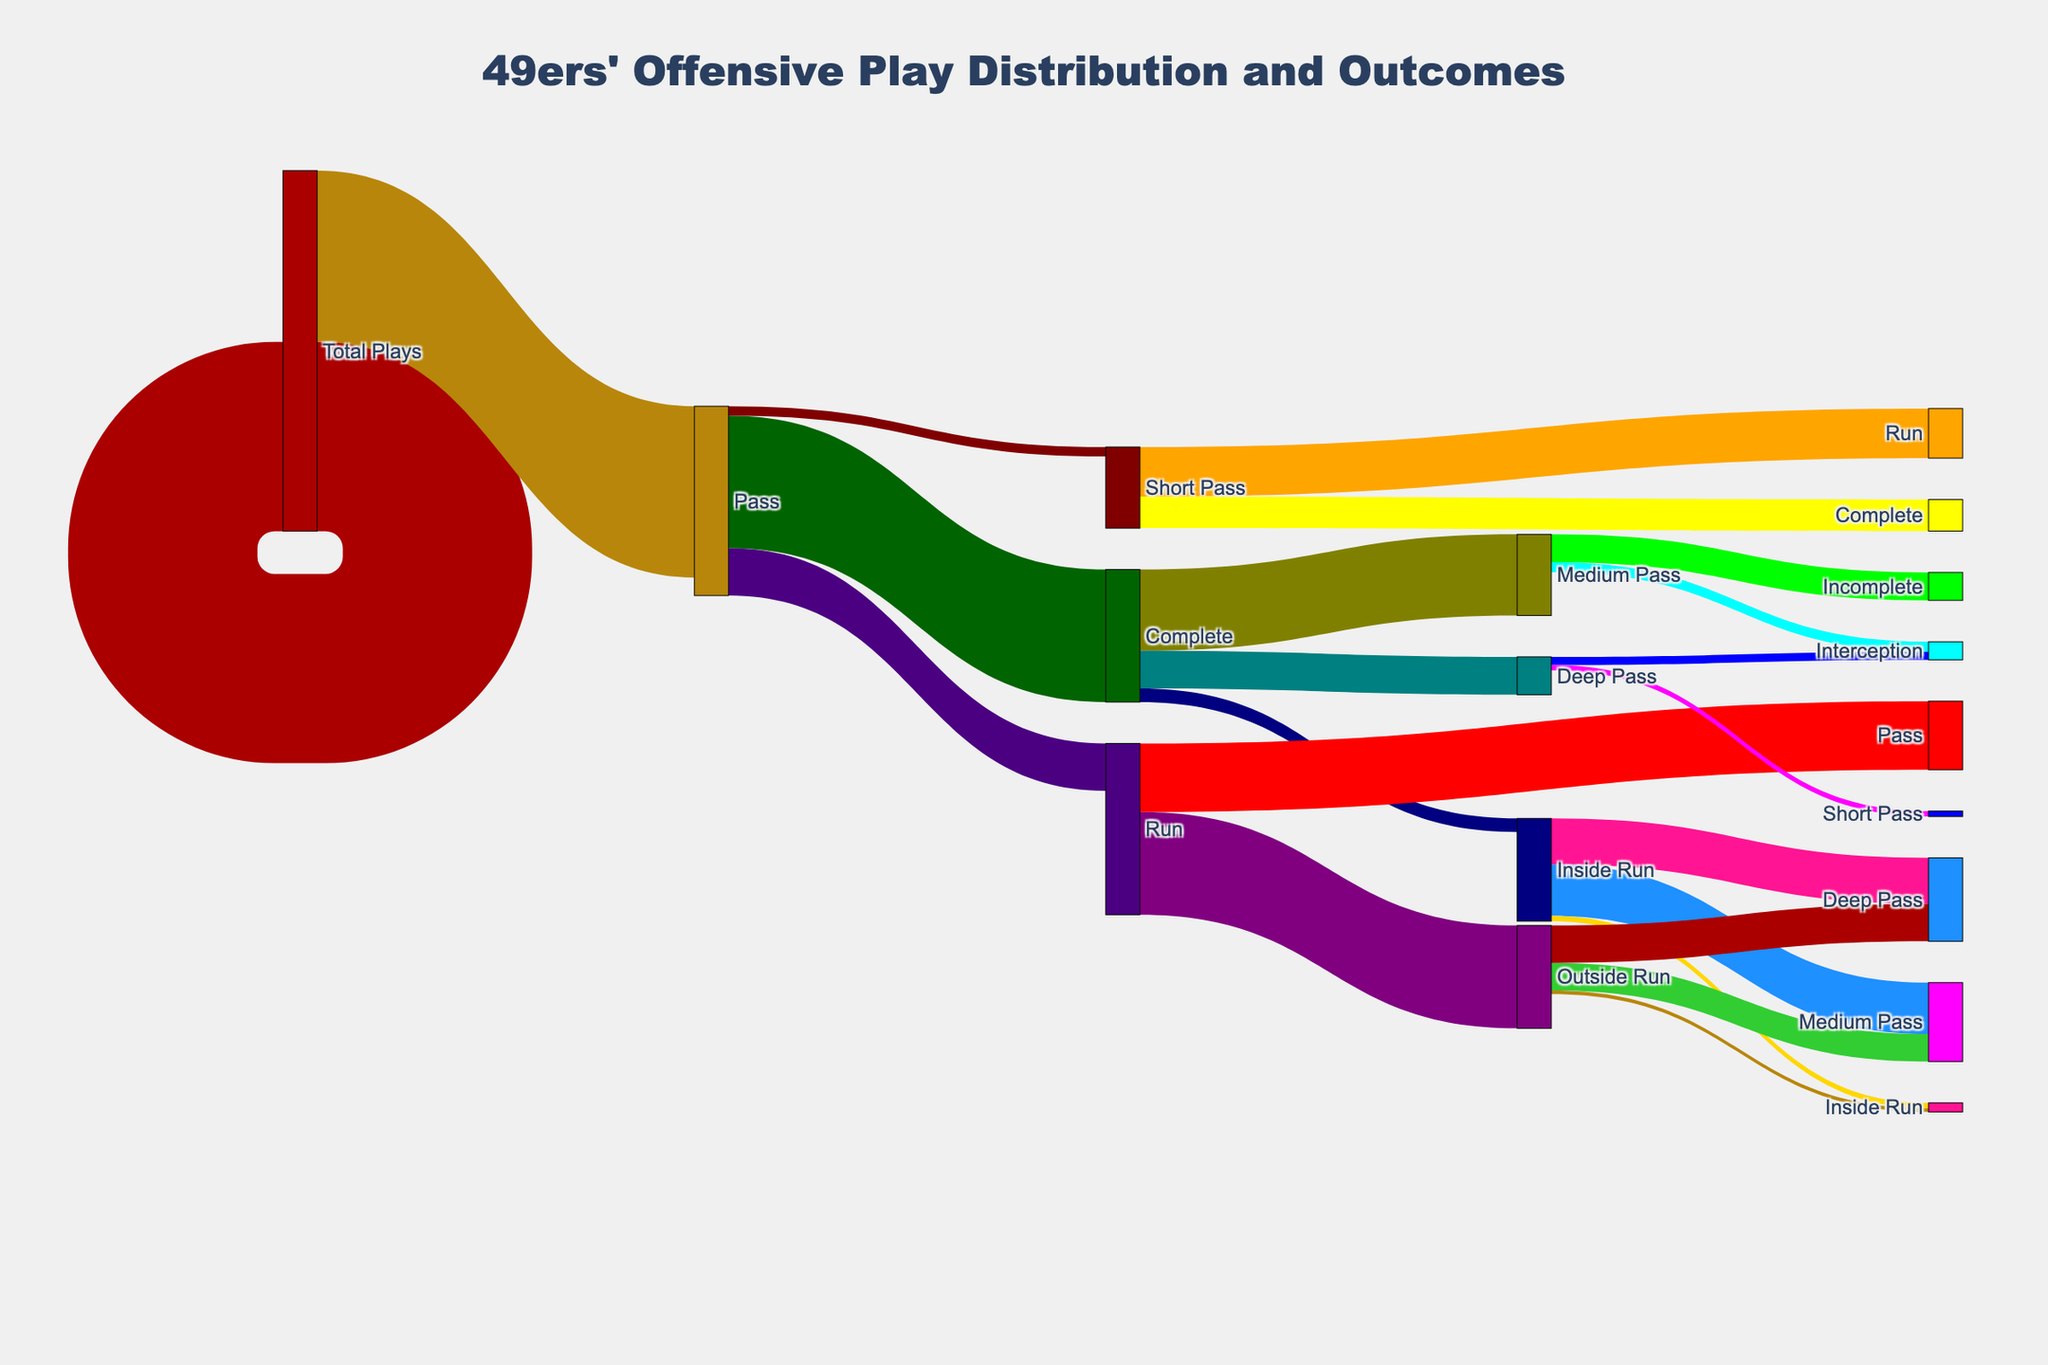What is the total number of offensive plays by the 49ers in the season? Add the total number of Pass plays (420) and Run plays (380). 420 + 380 = 800
Answer: 800 How many passing plays resulted in completions? Look at the link from "Pass" to "Complete"; the value is 294.
Answer: 294 Which type of run play was more frequent, inside or outside? Compare the values of "Inside Run" (228) and "Outside Run" (152). Inside Run is greater.
Answer: Inside Run What percentage of the 49ers’ passes were intercepted? Divide the number of Interceptions (21) by the total number of Pass plays (420) and multiply by 100. (21 / 420) * 100 ≈ 5%
Answer: 5% How many yards after catch were gained from short passes? Look at the link from "Short Pass" to "Yards After Catch"; the value is 110.
Answer: 110 Which passing depth (short, medium, deep) had the highest number of completions? Compare the values from "Complete" to "Short Pass" (180), "Medium Pass" (84), and "Deep Pass" (30). Short Pass is highest.
Answer: Short Pass What is the total number of runs that gained 4+ yards? Add the values from "Inside Run" to "Gain 4+ Yards" (102) and "Outside Run" to "Gain 4+ Yards" (83). 102 + 83 = 185
Answer: 185 Which play type (pass or run) resulted in a higher number of negative yard outcomes (losses)? Compare the values from "Inside Run" to "Loss" (12), "Outside Run" to "Loss" (8), and note there is no negative outcome detailed for Pass plays. The total loss for runs is 12 + 8 = 20.
Answer: Run How many more inside runs resulted in gain 0-3 yards than losses? Subtract the value of "Inside Run" to "Loss" (12) from "Inside Run" to "Gain 0-3 Yards" (114). 114 - 12 = 102
Answer: 102 What proportion of deep passes resulted in touchdowns? Divide the number of Touchdowns from Deep Pass (18) by the total number of Deep Pass completions (30). 18 / 30 = 0.6 or 60%
Answer: 60% 